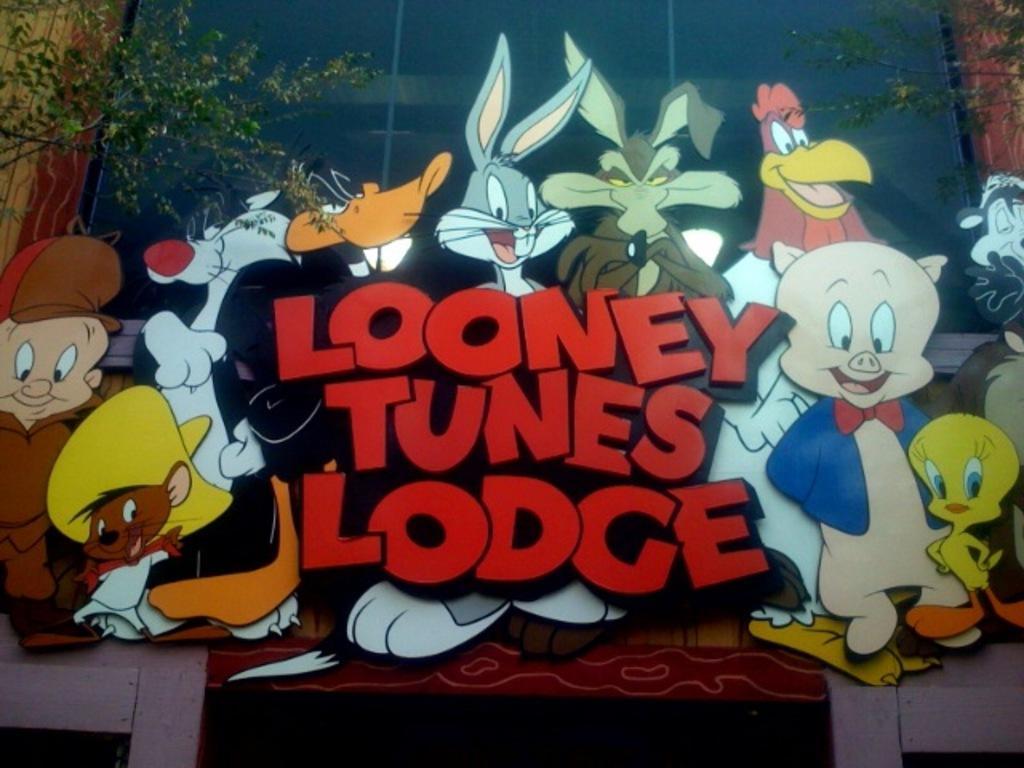Can you describe this image briefly? These are the cartoon characters, on the left side there is a tree. In the middle it is a glass wall of the building. 